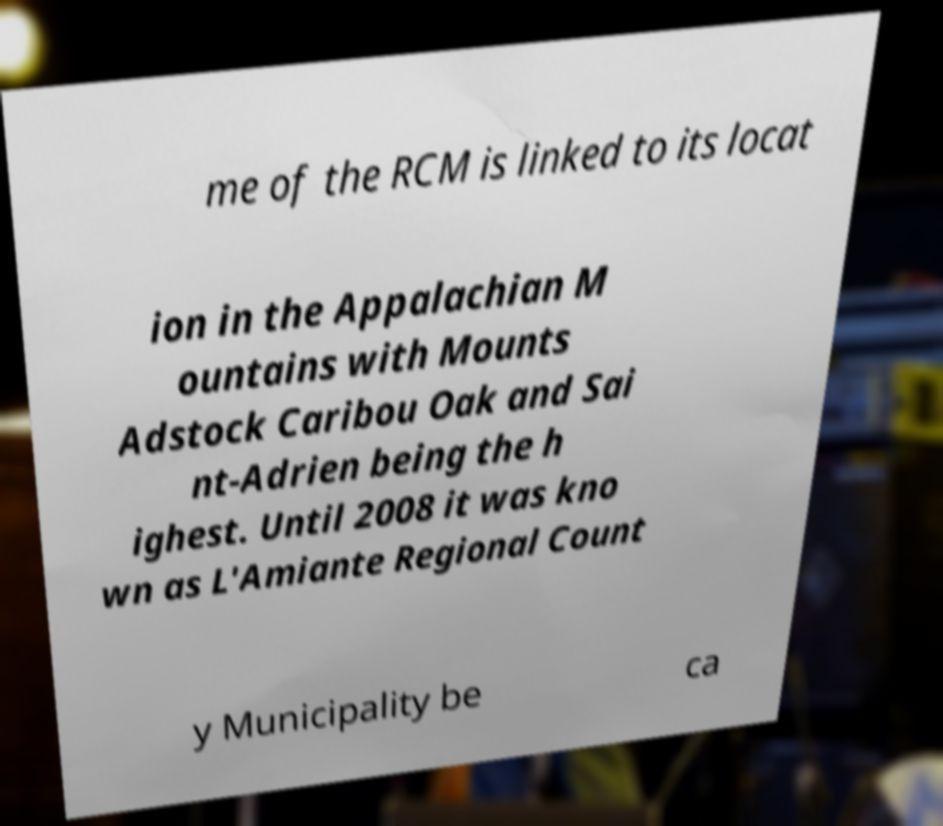Can you read and provide the text displayed in the image?This photo seems to have some interesting text. Can you extract and type it out for me? me of the RCM is linked to its locat ion in the Appalachian M ountains with Mounts Adstock Caribou Oak and Sai nt-Adrien being the h ighest. Until 2008 it was kno wn as L'Amiante Regional Count y Municipality be ca 